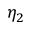Convert formula to latex. <formula><loc_0><loc_0><loc_500><loc_500>\eta _ { 2 }</formula> 